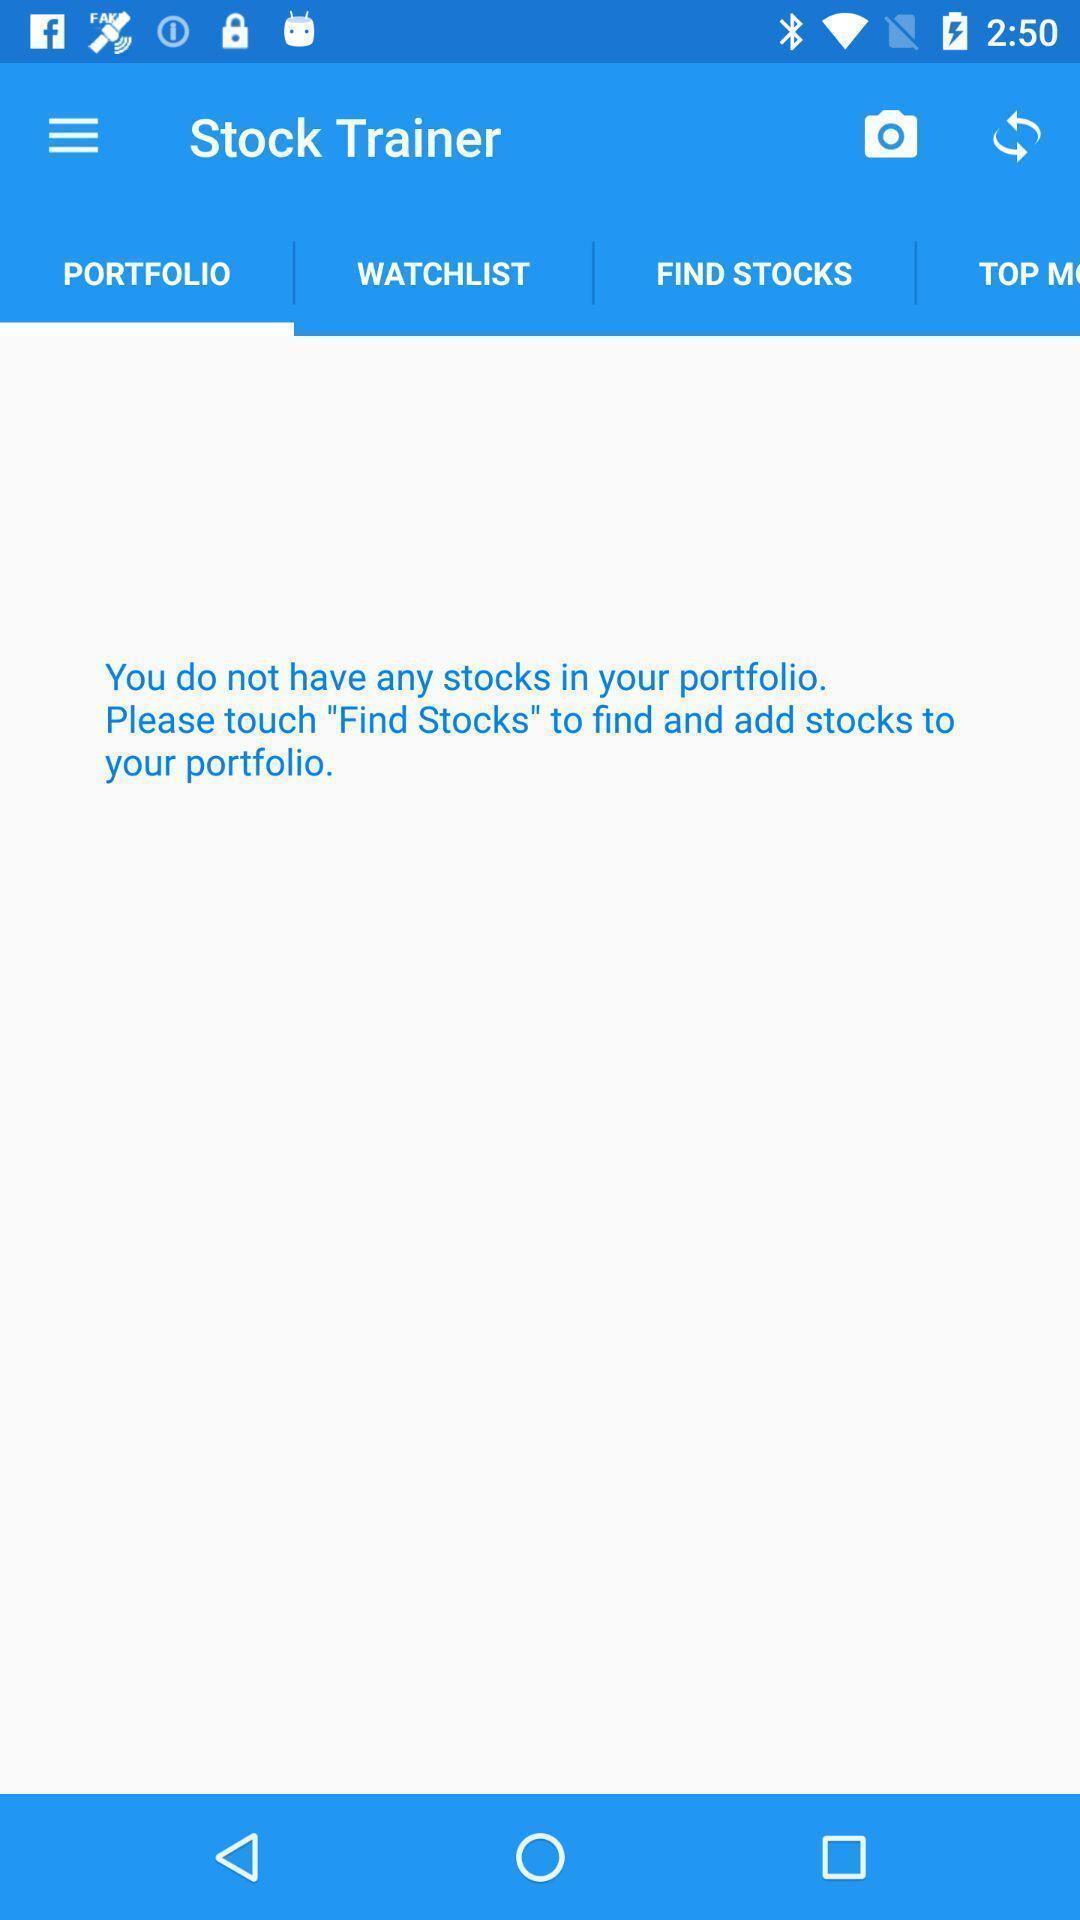What is the overall content of this screenshot? Stock status displaying in this page. 